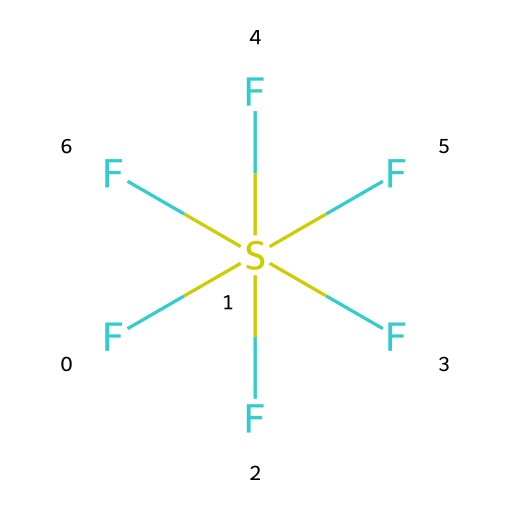What is the name of this chemical? The SMILES representation depicts a sulfur atom surrounded by six fluorine atoms, which corresponds to the chemical name sulfur hexafluoride.
Answer: sulfur hexafluoride How many fluorine atoms are present in the structure? The SMILES shows that the sulfur atom is bonded to six fluorine atoms, indicated by the notation (F)(F)(F)(F)(F)F.
Answer: six What type of chemical bonding is represented in this compound? The structure shows that sulfur forms bonds with fluorine atoms, specifically covalent bonds, as it shares electrons with each fluorine.
Answer: covalent Is sulfur hexafluoride a hypervalent compound? Sulfur has more than eight electrons in its valence shell (surrounded by six fluorine atoms), which makes it hypervalent.
Answer: yes How does the presence of fluorine affect the stability of sulfur hexafluoride? Fluorine is highly electronegative and stabilizes the compound by forming strong bonds with sulfur, contributing to the overall stability of the molecule.
Answer: stabilizes What is the molecular geometry of sulfur hexafluoride? The six fluorine atoms surrounding the central sulfur atom lead to an octahedral geometry due to spatial arrangement, which minimizes electron pair repulsion.
Answer: octahedral How does sulfur hexafluoride function in electrical insulation? The high electronegativity and large size of fluorine create a dielectric gas with excellent insulating properties, preventing electrical discharge.
Answer: excellent dielectric 